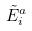Convert formula to latex. <formula><loc_0><loc_0><loc_500><loc_500>\tilde { E } _ { i } ^ { a }</formula> 